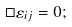Convert formula to latex. <formula><loc_0><loc_0><loc_500><loc_500>\square \varepsilon _ { i j } = 0 ;</formula> 